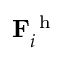Convert formula to latex. <formula><loc_0><loc_0><loc_500><loc_500>F _ { i } ^ { h }</formula> 